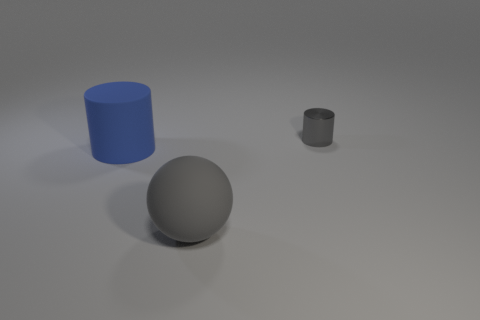There is a object that is the same color as the large rubber sphere; what size is it?
Your answer should be very brief. Small. Is the color of the metal cylinder the same as the large matte ball?
Your answer should be compact. Yes. What material is the tiny thing that is the same color as the large matte ball?
Your answer should be compact. Metal. There is a cylinder that is behind the big blue matte cylinder; what is its size?
Provide a succinct answer. Small. Is there any other thing of the same color as the big matte cylinder?
Keep it short and to the point. No. What is the shape of the other thing that is the same material as the big gray thing?
Make the answer very short. Cylinder. Do the cylinder in front of the small gray cylinder and the ball have the same material?
Your response must be concise. Yes. The thing that is the same color as the small metal cylinder is what shape?
Keep it short and to the point. Sphere. Do the big thing to the right of the matte cylinder and the object that is behind the big cylinder have the same color?
Offer a terse response. Yes. What number of cylinders are both in front of the gray metal object and right of the big gray thing?
Your response must be concise. 0. 